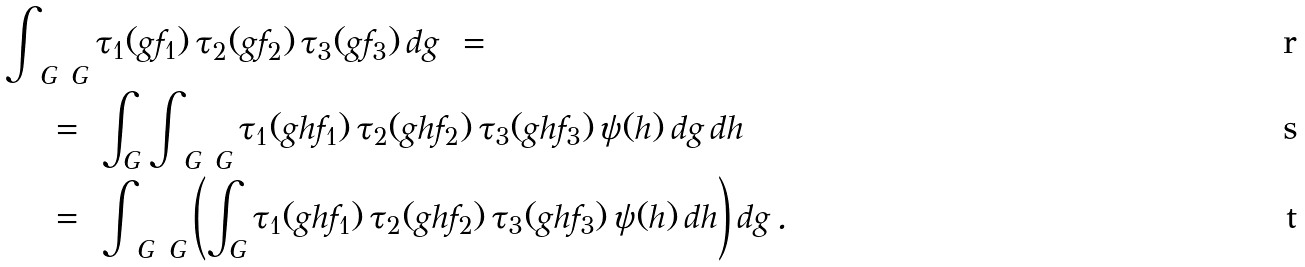Convert formula to latex. <formula><loc_0><loc_0><loc_500><loc_500>& \int _ { \ G \ G } \tau _ { 1 } ( g f _ { 1 } ) \, \tau _ { 2 } ( g f _ { 2 } ) \, \tau _ { 3 } ( g f _ { 3 } ) \, d g \ = \\ & \quad \ = \ \int _ { G } \int _ { \ G \ G } \tau _ { 1 } ( g h f _ { 1 } ) \, \tau _ { 2 } ( g h f _ { 2 } ) \, \tau _ { 3 } ( g h f _ { 3 } ) \, \psi ( h ) \, d g \, d h \\ & \quad \ = \ \int _ { \ G \ G } \left ( \int _ { G } \tau _ { 1 } ( g h f _ { 1 } ) \, \tau _ { 2 } ( g h f _ { 2 } ) \, \tau _ { 3 } ( g h f _ { 3 } ) \, \psi ( h ) \, d h \right ) d g \, .</formula> 